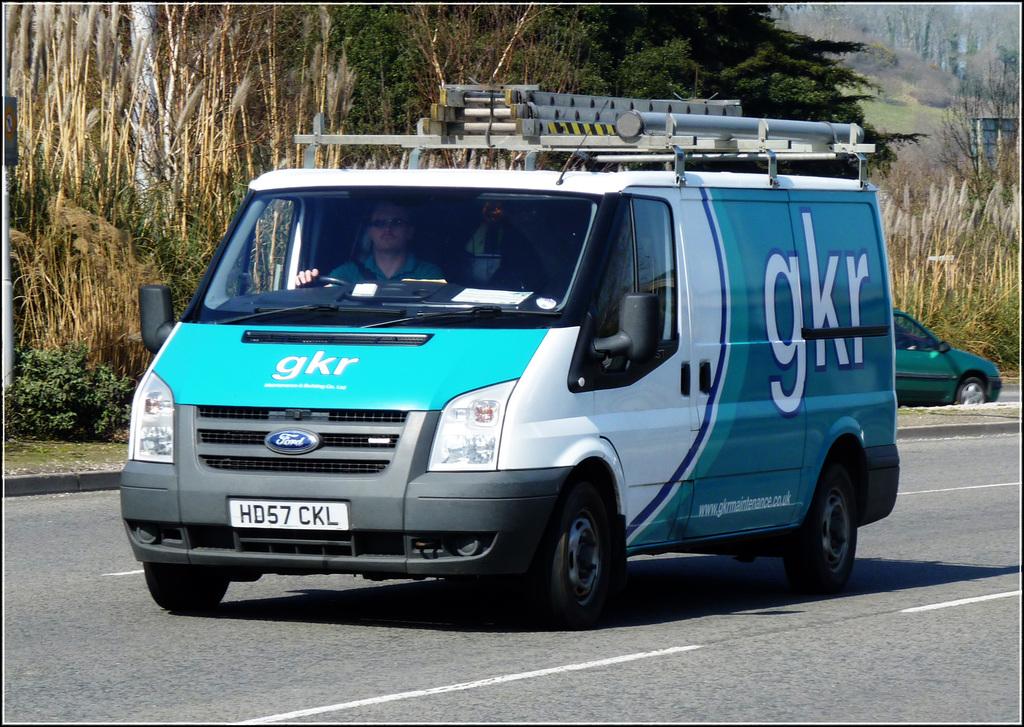What is the name of the business being advertised on this van?
Your answer should be compact. Gkr. What is the licence plate of the van?
Provide a short and direct response. Hd57 ckl. 